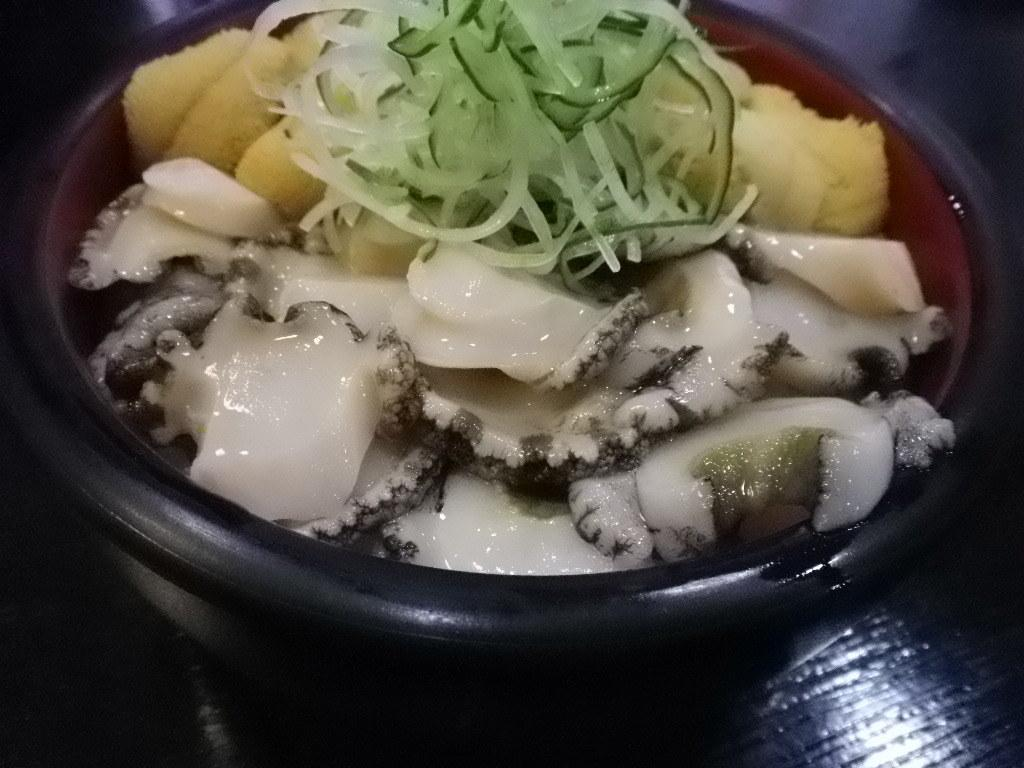What is the main subject of the image? There is a food item in the image. What color is the bowl that contains the food item? The bowl is black in color. What material is the surface beneath the bowl made of? The bowl is on a wooden surface. How does the marble interact with the food item in the image? There is no marble present in the image, so it cannot interact with the food item. 